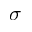<formula> <loc_0><loc_0><loc_500><loc_500>\sigma</formula> 